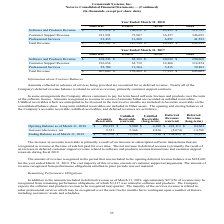From Commvault Systems's financial document, What were the reasons given for the change in accounts receivable and deferred revenue between March 2018 and March 2019 respectively? The document shows two values: increase in subscription software transactions that are recognized as revenue at the time of sale but paid for over time and increase in deferred customer support revenue related to software and products revenue transactions and customer support renewals during fiscal 2019.. From the document: "n accounts receivable is primarily a result of an increase in subscription software transactions that are recognized as revenue at the time of sale bu..." Also, How much is the opening balance for Deferred Revenue (current) and Deferred Revenue (long-term) respectively? The document shows two values: 241,113 and 84,661 (in thousands). From the document: "as of March 31, 2018 $ 152,219 $ 9,900 $ 4,380 $ 241,113 $ 84,661 ch 31, 2018 $ 152,219 $ 9,900 $ 4,380 $ 241,113 $ 84,661..." Also, What is the ending balance as of March 31, 2019 for Accounts Receivables? According to the financial document, $161,570 (in thousands). The relevant text states: "Ending Balance as of March 31, 2019 $ 161,570 $ 15,266 $ 7,216 $ 238,439 $ 99,257..." Also, can you calculate: What is the overall increase，net in opening and closing balances from March 2018 to March 2019? Based on the calculation: 9,351+5,366+2,836-2,674+14,596, the result is 29475 (in thousands). This is based on the information: "Increase/(decrease), net 9,351 5,366 2,836 (2,674) 14,596 Increase/(decrease), net 9,351 5,366 2,836 (2,674) 14,596 Increase/(decrease), net 9,351 5,366 2,836 (2,674) 14,596 Increase/(decrease), net 9..." The key data points involved are: 14,596, 2,674, 2,836. Also, From March 2018 to March 2019, amongst the company's accounts receivable, unbilled receivables (current and long-term), and deferred revenues (current and long-term), how many categories saw a net increase? Counting the relevant items in the document: Accounts Receivable ,  Unbilled Receivable (current) ,  Unbilled Receivable (long-term) , Deferred Revenue (long-term), I find 4 instances. The key data points involved are: Accounts Receivable, Deferred Revenue (long-term), Unbilled Receivable (current). Also, can you calculate: How many times more in current unbilled receivables than long-term unbilled receivables did the company have in its opening balance? Based on the calculation: 9,900/4,380, the result is 2.26. This is based on the information: "Opening Balance as of March 31, 2018 $ 152,219 $ 9,900 $ 4,380 $ 241,113 $ 84,661 Balance as of March 31, 2018 $ 152,219 $ 9,900 $ 4,380 $ 241,113 $ 84,661..." The key data points involved are: 4,380, 9,900. 